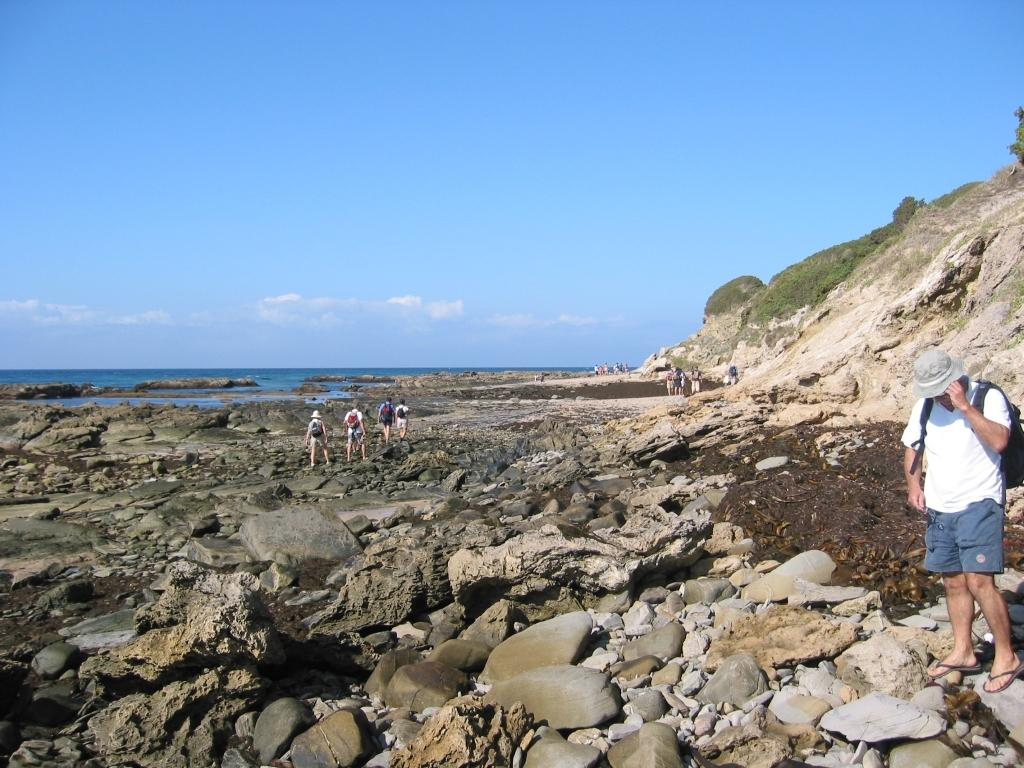How many persons are in the image? There are persons in the image. What are the persons wearing on their backs? The persons are wearing backpacks. What are the persons standing on? The persons are standing on stones. What type of landscape can be seen in the image? The image includes hills. What natural element is visible in the image? There is water visible in the image. What is visible in the sky in the image? The sky is visible in the image, and clouds are present. What type of plants are growing on the persons' backpacks in the image? There are no plants growing on the persons' backpacks in the image. What do the persons believe about the squirrel in the image? There is no squirrel present in the image, so it is not possible to determine what the persons might believe about it. 